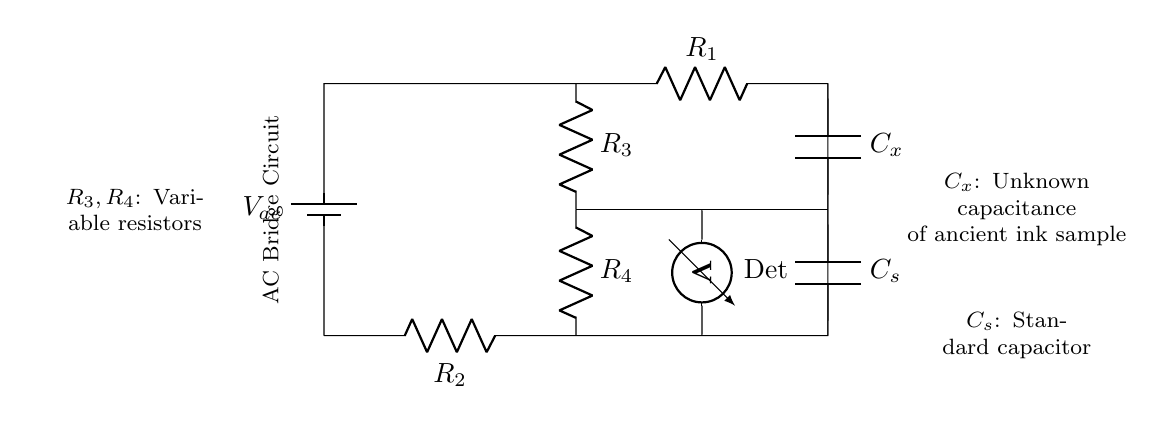What is the voltage source used in this circuit? The voltage source in this AC bridge circuit is labeled as V_ac, indicating it is an alternating current voltage source.
Answer: V_ac What components are used to measure the unknown capacitance? The unknown capacitance is measured using the capacitor labeled C_x, paired with a standard capacitor labeled C_s in the circuit.
Answer: C_x and C_s What type of resistors are R_3 and R_4? R_3 and R_4 are labeled as variable resistors, which means their resistance values can be adjusted to balance the bridge circuit.
Answer: Variable resistors How is the unknown capacitance related to the standard capacitor? The unknown capacitance C_x can be evaluated in relation to the standard capacitor C_s when the bridge is balanced, using the relationship C_x = (R_4 / R_3) * C_s.
Answer: Balanced bridge relationship What is the purpose of the voltmeter in this circuit? The voltmeter, labeled as Det, is used to measure the voltage difference across a specific part of the circuit to determine the condition of the bridge (balanced or unbalanced), which in turn helps in evaluating the unknown capacitance.
Answer: Measure voltage difference 